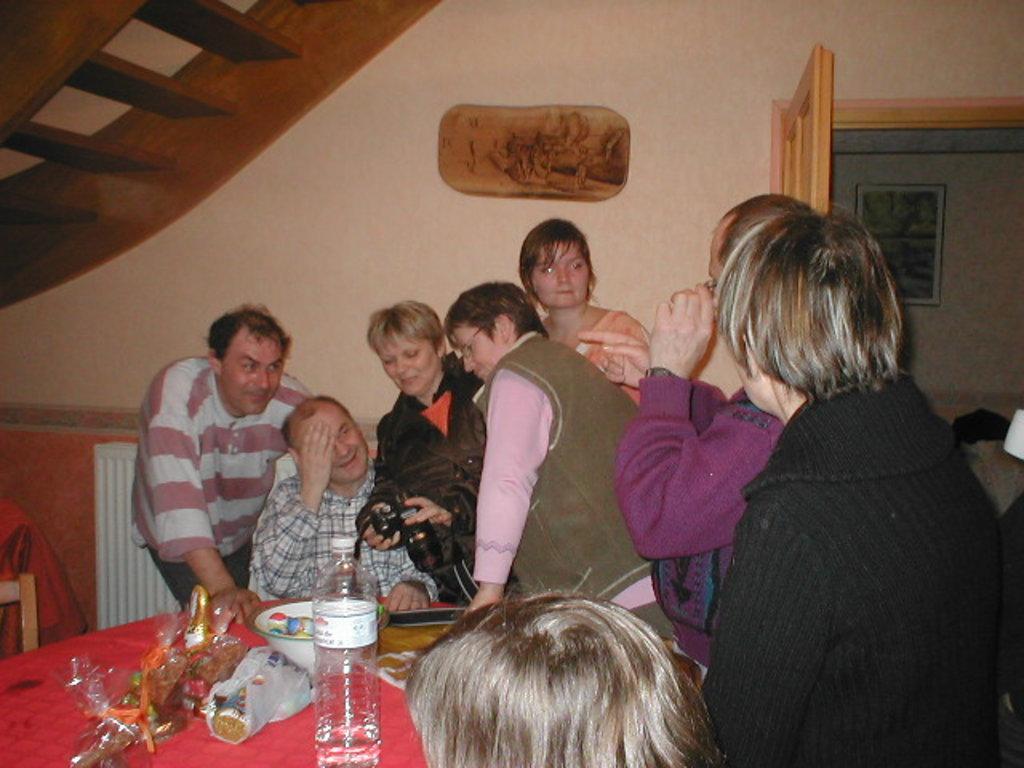Could you give a brief overview of what you see in this image? there are so many people around the table and woman holding the camera with the bowl and water bottle and some things. 